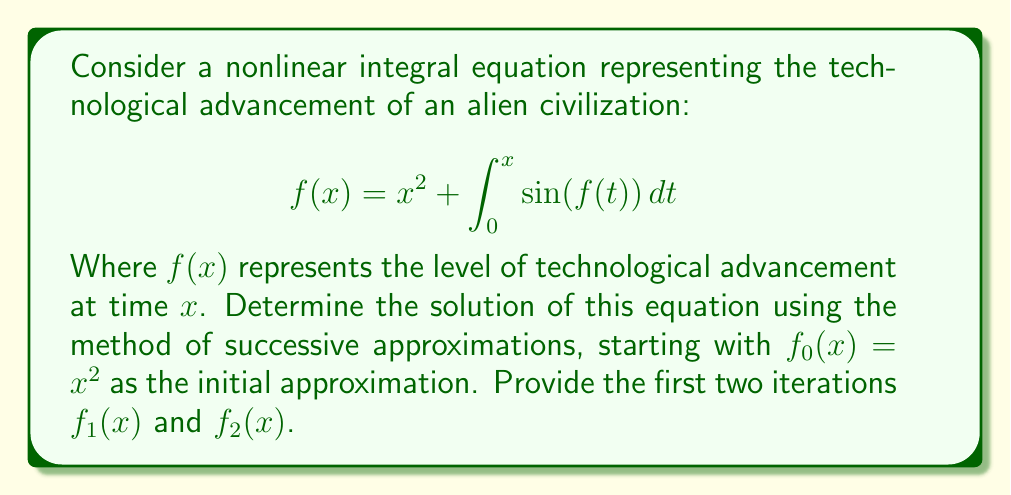Show me your answer to this math problem. To solve this nonlinear integral equation using successive approximations:

1. Start with the initial approximation $f_0(x) = x^2$

2. For the first iteration $f_1(x)$:
   $$f_1(x) = x^2 + \int_0^x \sin(f_0(t))\,dt = x^2 + \int_0^x \sin(t^2)\,dt$$
   This integral doesn't have an elementary antiderivative, so we'll leave it in this form.

3. For the second iteration $f_2(x)$:
   $$f_2(x) = x^2 + \int_0^x \sin(f_1(t))\,dt = x^2 + \int_0^x \sin(t^2 + \int_0^t \sin(s^2)\,ds)\,dt$$

4. Subsequent iterations would follow the same pattern, becoming increasingly complex.

5. In theory, as $n$ approaches infinity, $f_n(x)$ should converge to the true solution $f(x)$.

This problem illustrates how advanced alien technology might evolve nonlinearly, with each stage building upon previous advancements in a complex, interdependent manner.
Answer: $f_1(x) = x^2 + \int_0^x \sin(t^2)\,dt$, $f_2(x) = x^2 + \int_0^x \sin(t^2 + \int_0^t \sin(s^2)\,ds)\,dt$ 